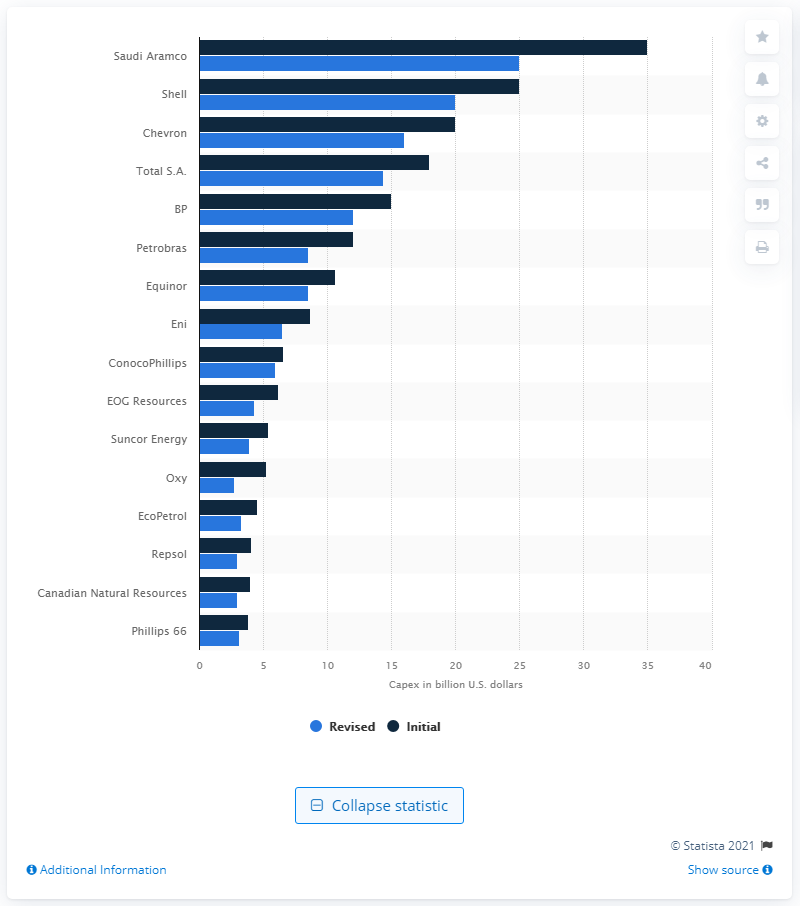Give some essential details in this illustration. At the beginning of 2020, Oxy's capex was approximately $5.2 billion. Oxy's 2020 capital expenditures totaled $2.7 billion. 